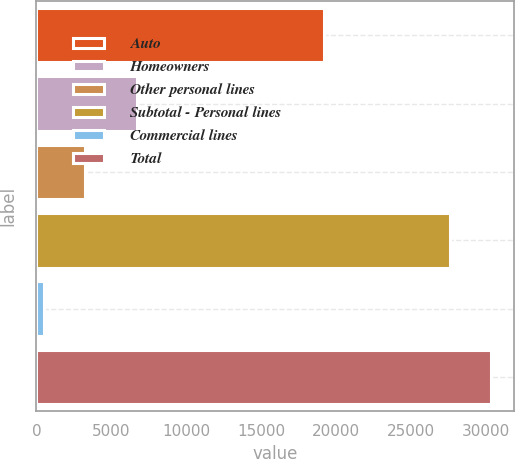Convert chart to OTSL. <chart><loc_0><loc_0><loc_500><loc_500><bar_chart><fcel>Auto<fcel>Homeowners<fcel>Other personal lines<fcel>Subtotal - Personal lines<fcel>Commercial lines<fcel>Total<nl><fcel>19209<fcel>6730<fcel>3255<fcel>27560<fcel>499<fcel>30316<nl></chart> 